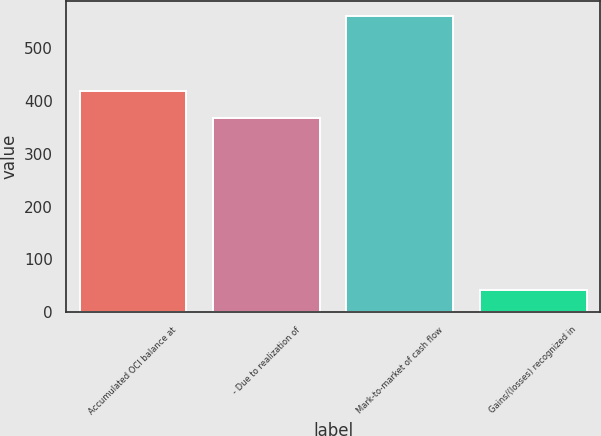Convert chart. <chart><loc_0><loc_0><loc_500><loc_500><bar_chart><fcel>Accumulated OCI balance at<fcel>- Due to realization of<fcel>Mark-to-market of cash flow<fcel>Gains/(losses) recognized in<nl><fcel>419.2<fcel>367.1<fcel>562<fcel>41<nl></chart> 